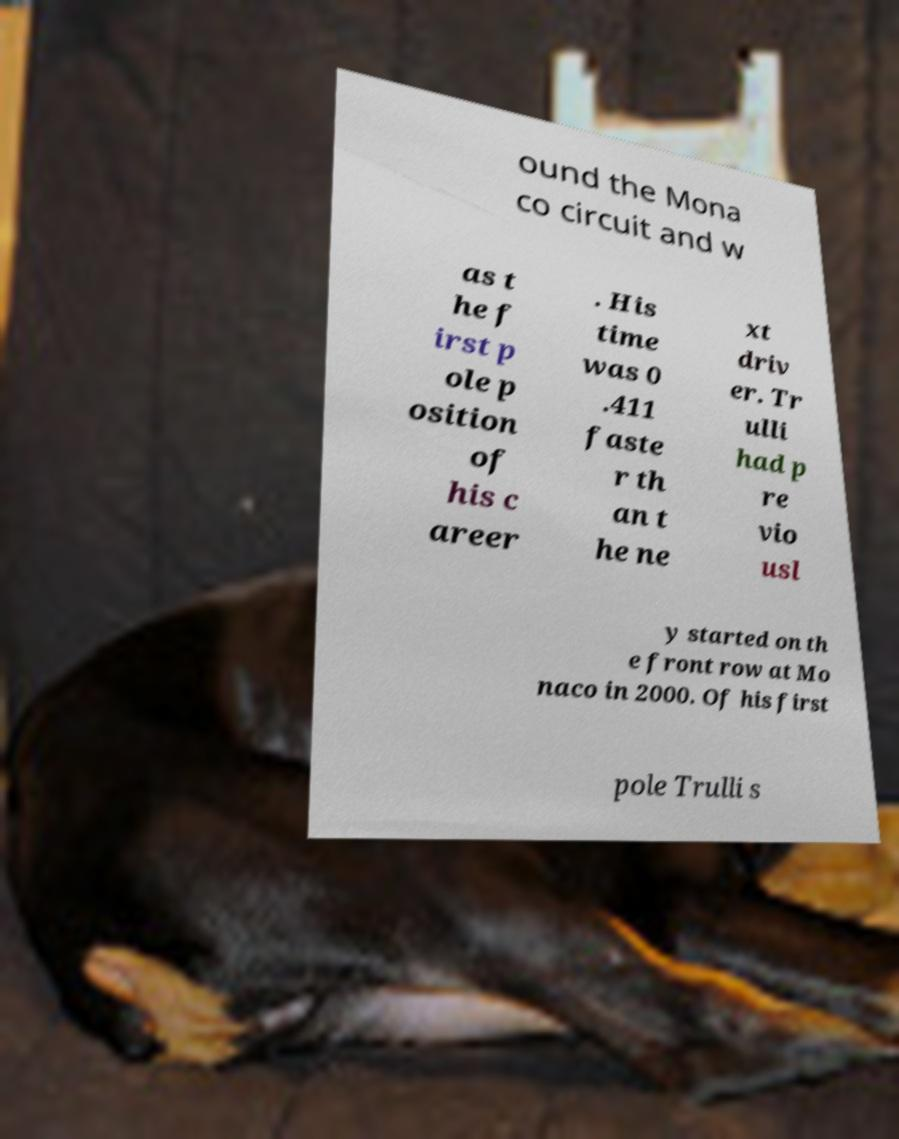Please read and relay the text visible in this image. What does it say? ound the Mona co circuit and w as t he f irst p ole p osition of his c areer . His time was 0 .411 faste r th an t he ne xt driv er. Tr ulli had p re vio usl y started on th e front row at Mo naco in 2000. Of his first pole Trulli s 